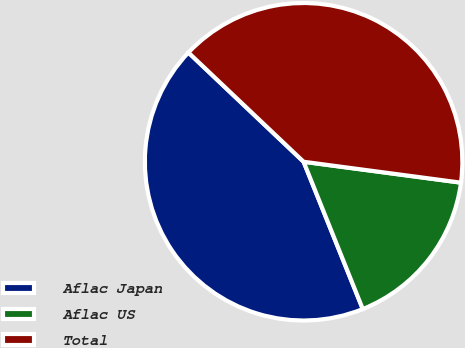<chart> <loc_0><loc_0><loc_500><loc_500><pie_chart><fcel>Aflac Japan<fcel>Aflac US<fcel>Total<nl><fcel>43.16%<fcel>16.82%<fcel>40.03%<nl></chart> 